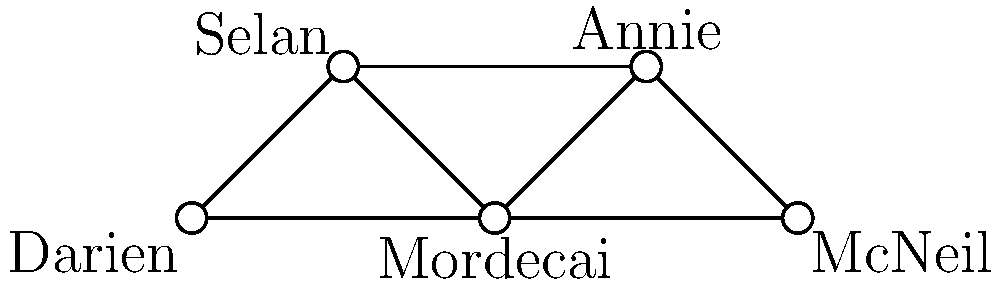In the Time Trax character interaction network, which character has the highest degree centrality, and what is their degree? To solve this question, we need to follow these steps:

1. Understand degree centrality: In graph theory, degree centrality is the number of edges connected to a node.

2. Count the connections for each character:
   - Darien: Connected to Selan and Mordecai (2 connections)
   - Selan: Connected to Darien, Mordecai, and Annie (3 connections)
   - Mordecai: Connected to Darien, Selan, Annie, and McNeil (4 connections)
   - Annie: Connected to Selan, Mordecai, and McNeil (3 connections)
   - McNeil: Connected to Mordecai and Annie (2 connections)

3. Identify the character with the highest number of connections:
   Mordecai has the highest number of connections with 4.

4. The degree of Mordecai is 4, which represents his degree centrality in this network.

Therefore, Mordecai has the highest degree centrality with a degree of 4.
Answer: Mordecai, 4 